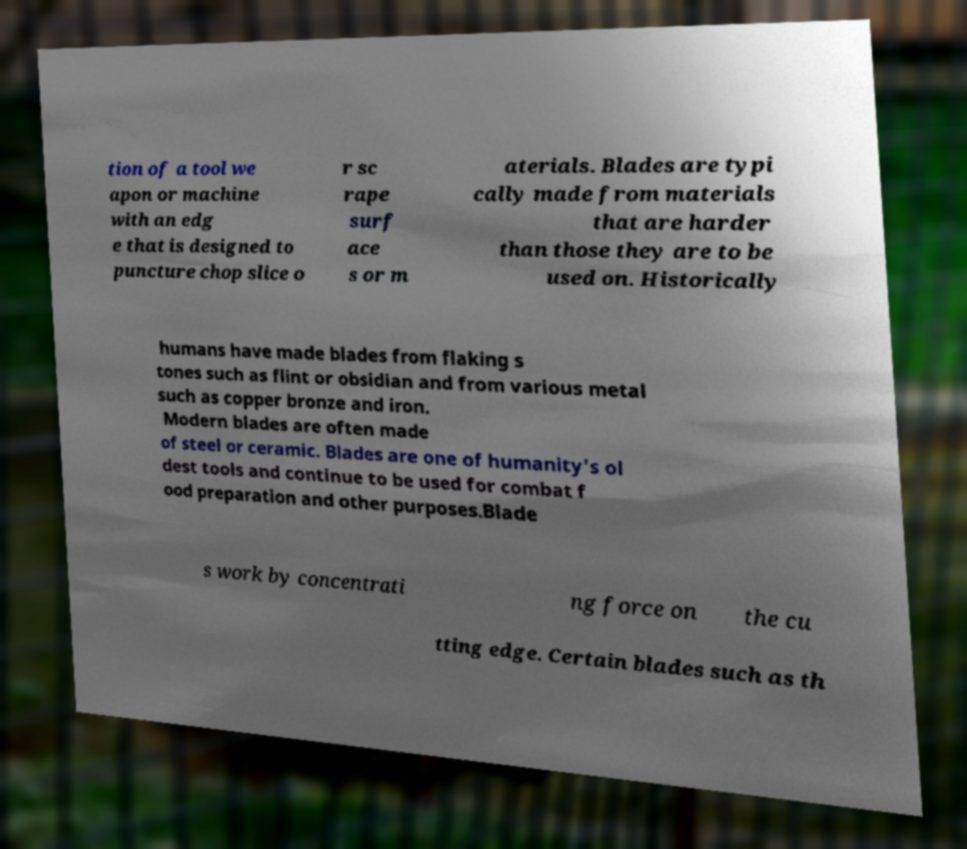Could you assist in decoding the text presented in this image and type it out clearly? tion of a tool we apon or machine with an edg e that is designed to puncture chop slice o r sc rape surf ace s or m aterials. Blades are typi cally made from materials that are harder than those they are to be used on. Historically humans have made blades from flaking s tones such as flint or obsidian and from various metal such as copper bronze and iron. Modern blades are often made of steel or ceramic. Blades are one of humanity's ol dest tools and continue to be used for combat f ood preparation and other purposes.Blade s work by concentrati ng force on the cu tting edge. Certain blades such as th 